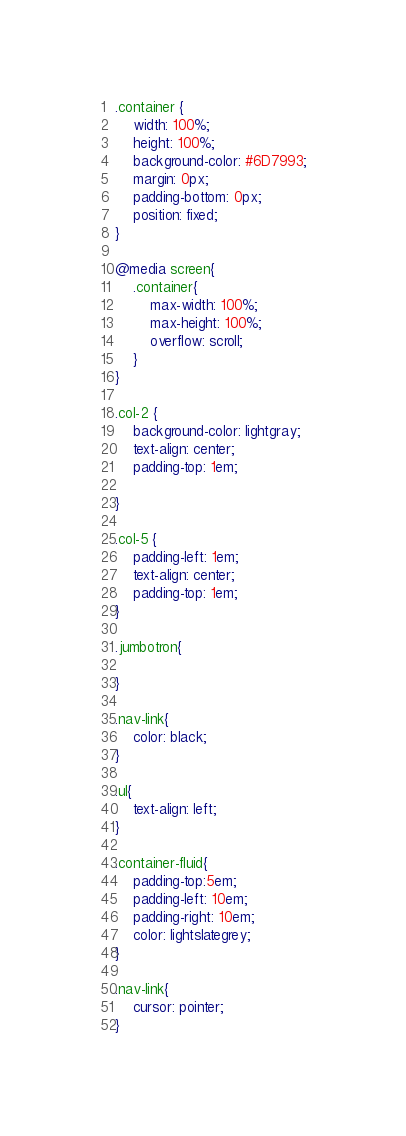<code> <loc_0><loc_0><loc_500><loc_500><_CSS_>.container {
    width: 100%;
    height: 100%;
    background-color: #6D7993;
    margin: 0px;
    padding-bottom: 0px;
    position: fixed;
}

@media screen{
    .container{
        max-width: 100%;
        max-height: 100%;
        overflow: scroll;
    }
}

.col-2 {
    background-color: lightgray;
    text-align: center;
    padding-top: 1em;
    
}

.col-5 {
    padding-left: 1em;
    text-align: center;
    padding-top: 1em;
}

.jumbotron{

}

.nav-link{
    color: black;
}

.ul{
    text-align: left;
}

.container-fluid{
    padding-top:5em;
    padding-left: 10em;
    padding-right: 10em;
    color: lightslategrey;
}

.nav-link{
    cursor: pointer;
}</code> 